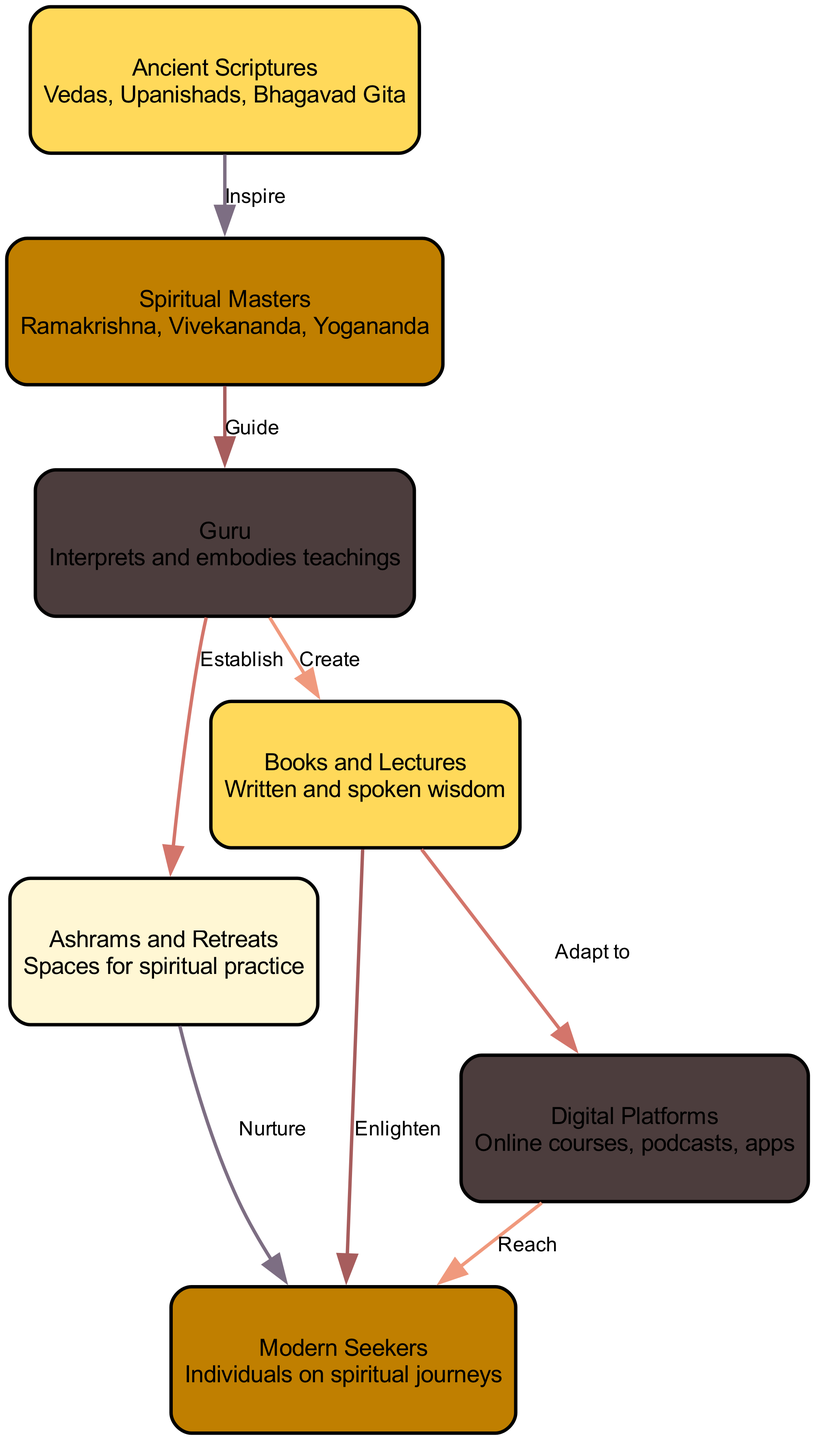What are the three ancient spiritual texts mentioned in the diagram? The diagram lists "Vedas, Upanishads, Bhagavad Gita" as examples of ancient scriptures.
Answer: Vedas, Upanishads, Bhagavad Gita Which spiritual master guides the Guru in the diagram? The arrows indicate that spiritual masters like Ramakrishna, Vivekananda, and Yogananda provide guidance to the Guru.
Answer: Spiritual Masters How many total nodes are present in the diagram? Counting the nodes listed, there are seven distinct nodes representing different elements in the spiritual wisdom flow.
Answer: 7 What is the primary role of the Guru according to the diagram? The diagram shows the Guru has two roles, which are to interpret and embody teachings.
Answer: Interpret and embody teachings Which element nurtures modern seekers in their spiritual journey? The arrow from Ashrams and Retreats to Modern Seekers indicates that ashrams nurture individuals on their spiritual journeys.
Answer: Ashrams and Retreats How do modern seekers reach wisdom through digital platforms? The diagram shows that digital platforms serve to reach modern seekers, suggesting that knowledge is disseminated via online courses, podcasts, and apps.
Answer: Digital Platforms What is the connection type between Books and Lectures and Modern Seekers? The arrow labeled "Enlighten" indicates that Books and Lectures provide enlightenment to Modern Seekers on their spiritual journey.
Answer: Enlighten What influences the Spiritual Masters in their teachings? The connection labeled "Inspire" from Ancient Scriptures to Spiritual Masters shows that they are influenced by the wisdom in ancient texts.
Answer: Ancient Scriptures How many unique connection types are there in the diagram? By examining the connections displayed, there are a total of eight unique relationships between the elements represented in the diagram.
Answer: 8 